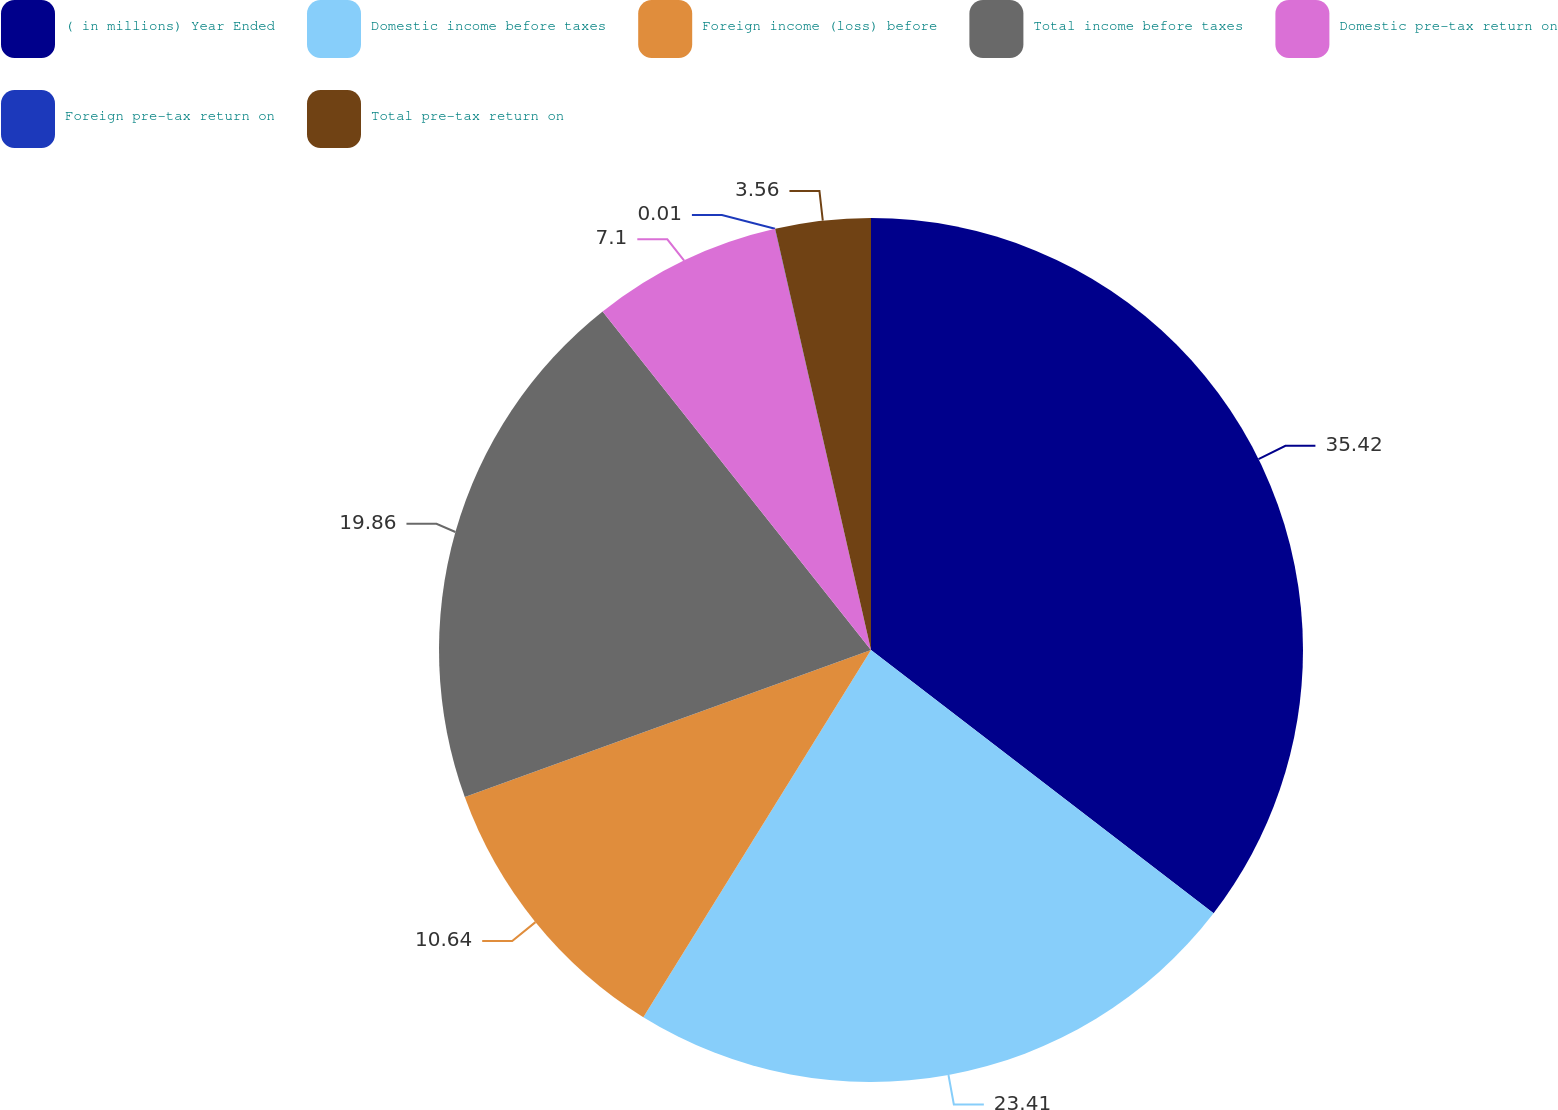Convert chart. <chart><loc_0><loc_0><loc_500><loc_500><pie_chart><fcel>( in millions) Year Ended<fcel>Domestic income before taxes<fcel>Foreign income (loss) before<fcel>Total income before taxes<fcel>Domestic pre-tax return on<fcel>Foreign pre-tax return on<fcel>Total pre-tax return on<nl><fcel>35.43%<fcel>23.41%<fcel>10.64%<fcel>19.86%<fcel>7.1%<fcel>0.01%<fcel>3.56%<nl></chart> 